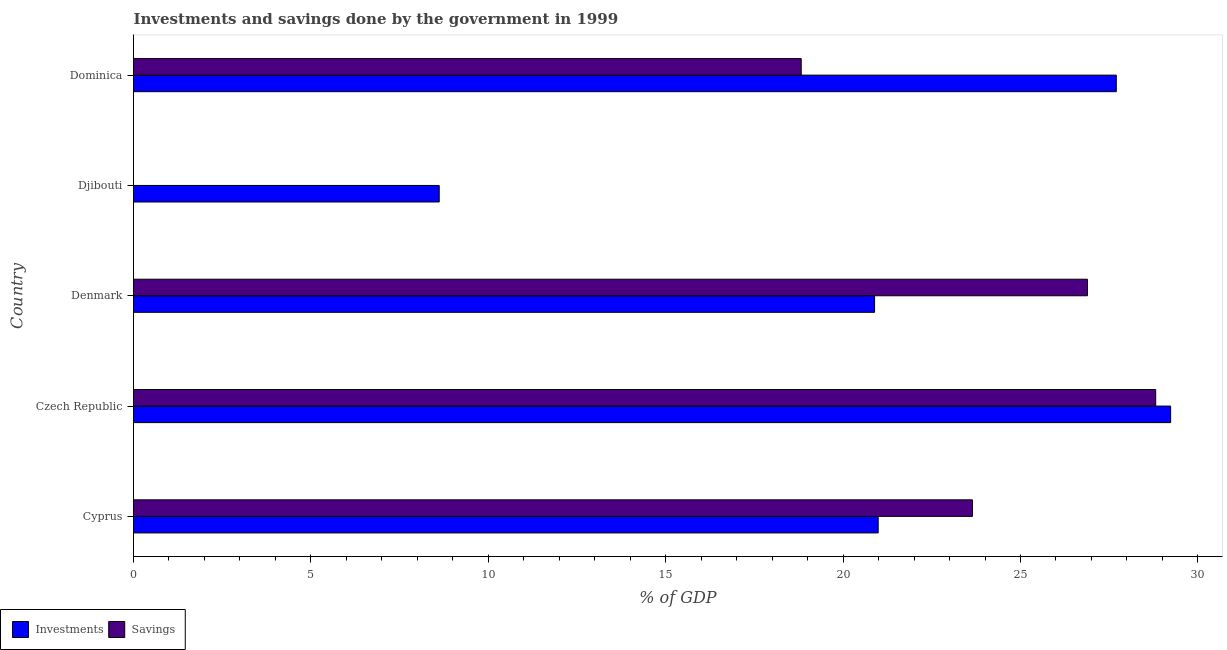How many different coloured bars are there?
Your answer should be very brief. 2. Are the number of bars on each tick of the Y-axis equal?
Provide a succinct answer. No. How many bars are there on the 1st tick from the top?
Your answer should be very brief. 2. What is the label of the 3rd group of bars from the top?
Provide a succinct answer. Denmark. In how many cases, is the number of bars for a given country not equal to the number of legend labels?
Your answer should be compact. 1. What is the investments of government in Dominica?
Your answer should be very brief. 27.7. Across all countries, what is the maximum savings of government?
Provide a succinct answer. 28.81. Across all countries, what is the minimum savings of government?
Provide a short and direct response. 0. In which country was the savings of government maximum?
Keep it short and to the point. Czech Republic. What is the total savings of government in the graph?
Provide a short and direct response. 98.17. What is the difference between the investments of government in Denmark and that in Dominica?
Provide a short and direct response. -6.81. What is the difference between the investments of government in Cyprus and the savings of government in Denmark?
Provide a succinct answer. -5.9. What is the average investments of government per country?
Keep it short and to the point. 21.49. What is the difference between the savings of government and investments of government in Dominica?
Your answer should be very brief. -8.88. In how many countries, is the investments of government greater than 2 %?
Your answer should be very brief. 5. What is the ratio of the savings of government in Cyprus to that in Denmark?
Offer a terse response. 0.88. Is the savings of government in Czech Republic less than that in Denmark?
Your response must be concise. No. What is the difference between the highest and the second highest savings of government?
Your answer should be very brief. 1.92. What is the difference between the highest and the lowest savings of government?
Provide a succinct answer. 28.81. In how many countries, is the investments of government greater than the average investments of government taken over all countries?
Offer a very short reply. 2. Is the sum of the investments of government in Djibouti and Dominica greater than the maximum savings of government across all countries?
Your answer should be very brief. Yes. How many bars are there?
Your answer should be compact. 9. Are the values on the major ticks of X-axis written in scientific E-notation?
Keep it short and to the point. No. Does the graph contain any zero values?
Your answer should be compact. Yes. Does the graph contain grids?
Your response must be concise. No. How are the legend labels stacked?
Provide a succinct answer. Horizontal. What is the title of the graph?
Provide a succinct answer. Investments and savings done by the government in 1999. What is the label or title of the X-axis?
Ensure brevity in your answer.  % of GDP. What is the label or title of the Y-axis?
Keep it short and to the point. Country. What is the % of GDP in Investments in Cyprus?
Ensure brevity in your answer.  20.99. What is the % of GDP in Savings in Cyprus?
Your response must be concise. 23.65. What is the % of GDP in Investments in Czech Republic?
Your response must be concise. 29.23. What is the % of GDP of Savings in Czech Republic?
Keep it short and to the point. 28.81. What is the % of GDP of Investments in Denmark?
Ensure brevity in your answer.  20.89. What is the % of GDP in Savings in Denmark?
Provide a short and direct response. 26.89. What is the % of GDP in Investments in Djibouti?
Your answer should be compact. 8.62. What is the % of GDP in Investments in Dominica?
Keep it short and to the point. 27.7. What is the % of GDP in Savings in Dominica?
Keep it short and to the point. 18.82. Across all countries, what is the maximum % of GDP in Investments?
Offer a terse response. 29.23. Across all countries, what is the maximum % of GDP of Savings?
Your answer should be compact. 28.81. Across all countries, what is the minimum % of GDP of Investments?
Make the answer very short. 8.62. What is the total % of GDP in Investments in the graph?
Your response must be concise. 107.43. What is the total % of GDP of Savings in the graph?
Offer a terse response. 98.17. What is the difference between the % of GDP of Investments in Cyprus and that in Czech Republic?
Ensure brevity in your answer.  -8.24. What is the difference between the % of GDP in Savings in Cyprus and that in Czech Republic?
Keep it short and to the point. -5.16. What is the difference between the % of GDP in Investments in Cyprus and that in Denmark?
Your response must be concise. 0.1. What is the difference between the % of GDP of Savings in Cyprus and that in Denmark?
Your answer should be compact. -3.24. What is the difference between the % of GDP in Investments in Cyprus and that in Djibouti?
Ensure brevity in your answer.  12.37. What is the difference between the % of GDP in Investments in Cyprus and that in Dominica?
Ensure brevity in your answer.  -6.71. What is the difference between the % of GDP of Savings in Cyprus and that in Dominica?
Your answer should be very brief. 4.83. What is the difference between the % of GDP of Investments in Czech Republic and that in Denmark?
Your answer should be very brief. 8.34. What is the difference between the % of GDP in Savings in Czech Republic and that in Denmark?
Ensure brevity in your answer.  1.92. What is the difference between the % of GDP in Investments in Czech Republic and that in Djibouti?
Keep it short and to the point. 20.62. What is the difference between the % of GDP in Investments in Czech Republic and that in Dominica?
Your answer should be compact. 1.53. What is the difference between the % of GDP in Savings in Czech Republic and that in Dominica?
Your answer should be compact. 9.99. What is the difference between the % of GDP in Investments in Denmark and that in Djibouti?
Your answer should be compact. 12.27. What is the difference between the % of GDP of Investments in Denmark and that in Dominica?
Your answer should be compact. -6.81. What is the difference between the % of GDP of Savings in Denmark and that in Dominica?
Your answer should be compact. 8.07. What is the difference between the % of GDP of Investments in Djibouti and that in Dominica?
Your response must be concise. -19.08. What is the difference between the % of GDP in Investments in Cyprus and the % of GDP in Savings in Czech Republic?
Ensure brevity in your answer.  -7.82. What is the difference between the % of GDP in Investments in Cyprus and the % of GDP in Savings in Denmark?
Give a very brief answer. -5.9. What is the difference between the % of GDP in Investments in Cyprus and the % of GDP in Savings in Dominica?
Your answer should be compact. 2.17. What is the difference between the % of GDP in Investments in Czech Republic and the % of GDP in Savings in Denmark?
Provide a succinct answer. 2.35. What is the difference between the % of GDP of Investments in Czech Republic and the % of GDP of Savings in Dominica?
Give a very brief answer. 10.41. What is the difference between the % of GDP in Investments in Denmark and the % of GDP in Savings in Dominica?
Give a very brief answer. 2.07. What is the difference between the % of GDP in Investments in Djibouti and the % of GDP in Savings in Dominica?
Make the answer very short. -10.2. What is the average % of GDP in Investments per country?
Make the answer very short. 21.49. What is the average % of GDP of Savings per country?
Ensure brevity in your answer.  19.63. What is the difference between the % of GDP in Investments and % of GDP in Savings in Cyprus?
Offer a very short reply. -2.66. What is the difference between the % of GDP of Investments and % of GDP of Savings in Czech Republic?
Make the answer very short. 0.42. What is the difference between the % of GDP of Investments and % of GDP of Savings in Denmark?
Your response must be concise. -6. What is the difference between the % of GDP in Investments and % of GDP in Savings in Dominica?
Provide a succinct answer. 8.88. What is the ratio of the % of GDP in Investments in Cyprus to that in Czech Republic?
Your answer should be very brief. 0.72. What is the ratio of the % of GDP of Savings in Cyprus to that in Czech Republic?
Your answer should be compact. 0.82. What is the ratio of the % of GDP of Savings in Cyprus to that in Denmark?
Provide a succinct answer. 0.88. What is the ratio of the % of GDP of Investments in Cyprus to that in Djibouti?
Your response must be concise. 2.44. What is the ratio of the % of GDP of Investments in Cyprus to that in Dominica?
Keep it short and to the point. 0.76. What is the ratio of the % of GDP of Savings in Cyprus to that in Dominica?
Keep it short and to the point. 1.26. What is the ratio of the % of GDP in Investments in Czech Republic to that in Denmark?
Offer a terse response. 1.4. What is the ratio of the % of GDP of Savings in Czech Republic to that in Denmark?
Your response must be concise. 1.07. What is the ratio of the % of GDP in Investments in Czech Republic to that in Djibouti?
Provide a succinct answer. 3.39. What is the ratio of the % of GDP in Investments in Czech Republic to that in Dominica?
Provide a short and direct response. 1.06. What is the ratio of the % of GDP in Savings in Czech Republic to that in Dominica?
Your answer should be very brief. 1.53. What is the ratio of the % of GDP in Investments in Denmark to that in Djibouti?
Make the answer very short. 2.42. What is the ratio of the % of GDP in Investments in Denmark to that in Dominica?
Keep it short and to the point. 0.75. What is the ratio of the % of GDP in Savings in Denmark to that in Dominica?
Give a very brief answer. 1.43. What is the ratio of the % of GDP of Investments in Djibouti to that in Dominica?
Provide a short and direct response. 0.31. What is the difference between the highest and the second highest % of GDP of Investments?
Ensure brevity in your answer.  1.53. What is the difference between the highest and the second highest % of GDP in Savings?
Make the answer very short. 1.92. What is the difference between the highest and the lowest % of GDP of Investments?
Ensure brevity in your answer.  20.62. What is the difference between the highest and the lowest % of GDP in Savings?
Offer a terse response. 28.81. 